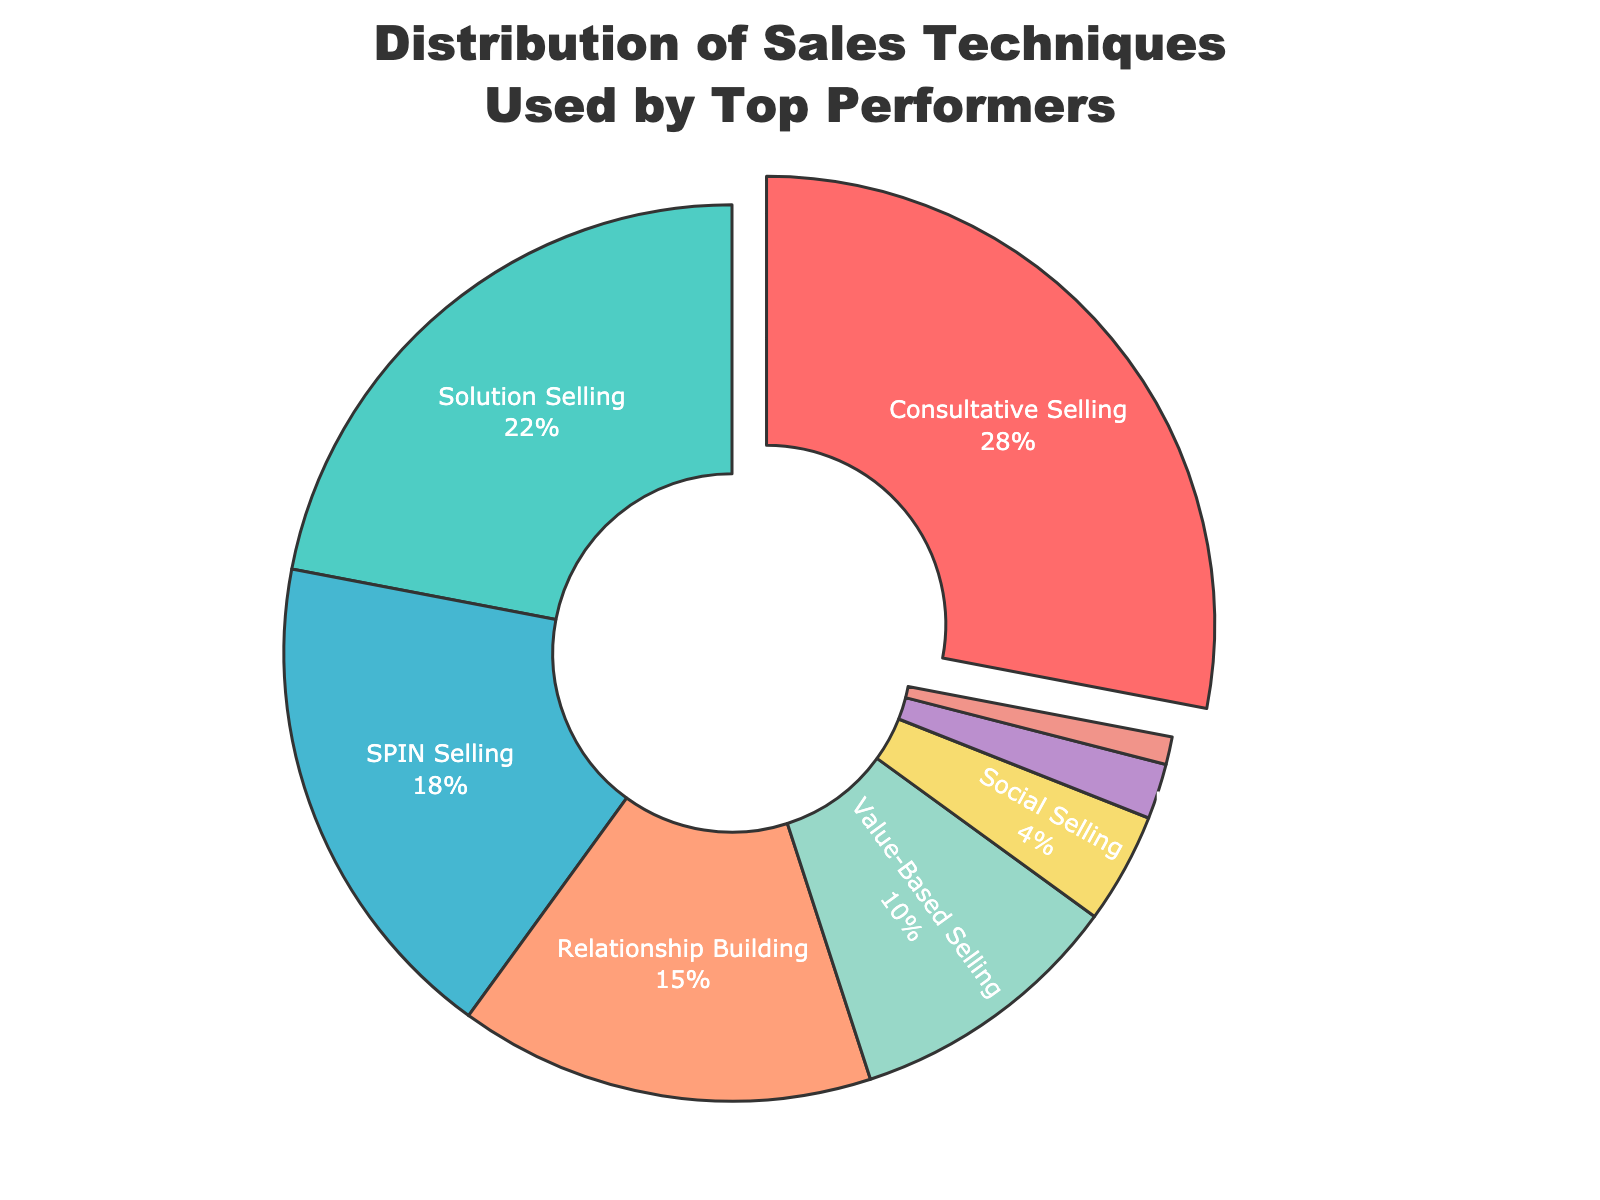Which sales technique is used the most by top performers? The pie chart shows the distribution of sales techniques with Consultative Selling having the largest segment.
Answer: Consultative Selling What percentage of top performers use Solution Selling? By referring to the pie chart, Solution Selling accounts for 22% of the sales techniques used by top performers.
Answer: 22% How much greater is the percentage of top performers who use Consultative Selling compared to those who use Cold Calling? The percentage for Consultative Selling is 28% and for Cold Calling is 2%. The difference is 28% - 2% = 26%.
Answer: 26% What is the combined percentage of top performers using Relationship Building and Value-Based Selling? Relationship Building accounts for 15% and Value-Based Selling accounts for 10%. The combined percentage is 15% + 10% = 25%.
Answer: 25% Which sales techniques are used by more than 20% of top performers? The pie chart shows that both Consultative Selling (28%) and Solution Selling (22%) are used by more than 20% of top performers.
Answer: Consultative Selling, Solution Selling What is the total percentage of top performers using SPIN Selling, Social Selling, and Upselling combined? SPIN Selling is used by 18%, Social Selling by 4%, and Upselling by 1%. The total combined percentage is 18% + 4% + 1% = 23%.
Answer: 23% Which segment is depicted in red color? By identifying the red segment on the pie chart, it represents Consultative Selling.
Answer: Consultative Selling How does the percentage of top performers using SPIN Selling compare to those using Social Selling? SPIN Selling is used by 18% of top performers, while Social Selling is used by 4%. Therefore, SPIN Selling is used more.
Answer: SPIN Selling What percentage of top performers use techniques other than Consultative Selling? Consultative Selling is used by 28%, so the percentage for other techniques is 100% - 28% = 72%.
Answer: 72% Which sales technique has the smallest segment in the pie chart? The smallest segment in the pie chart represents Upselling, which accounts for 1%.
Answer: Upselling 